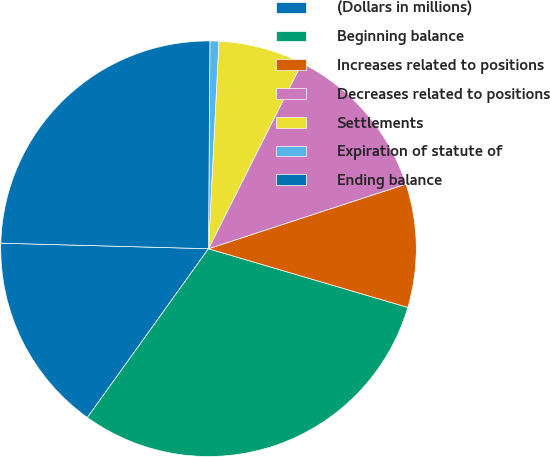<chart> <loc_0><loc_0><loc_500><loc_500><pie_chart><fcel>(Dollars in millions)<fcel>Beginning balance<fcel>Increases related to positions<fcel>Decreases related to positions<fcel>Settlements<fcel>Expiration of statute of<fcel>Ending balance<nl><fcel>15.52%<fcel>30.35%<fcel>9.59%<fcel>12.55%<fcel>6.62%<fcel>0.69%<fcel>24.68%<nl></chart> 